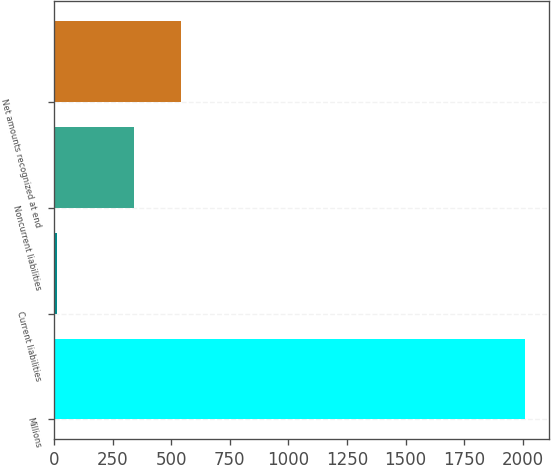<chart> <loc_0><loc_0><loc_500><loc_500><bar_chart><fcel>Millions<fcel>Current liabilities<fcel>Noncurrent liabilities<fcel>Net amounts recognized at end<nl><fcel>2010<fcel>15<fcel>341<fcel>540.5<nl></chart> 